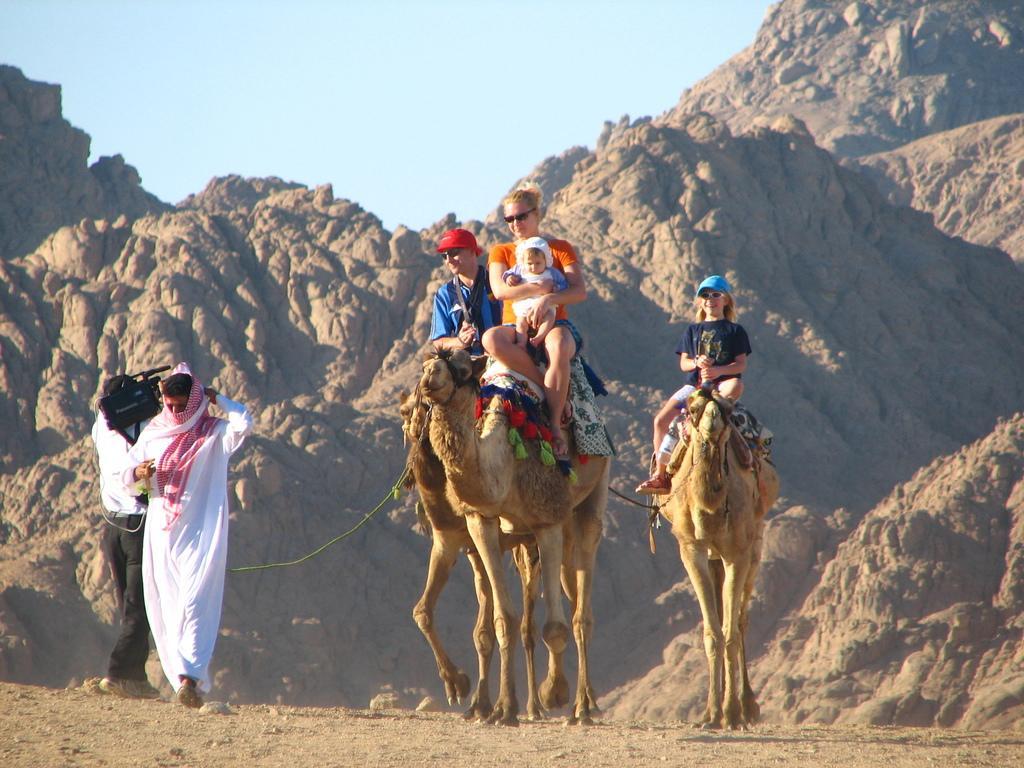In one or two sentences, can you explain what this image depicts? In this picture we can see there are some people riding the camels. A woman is holding a baby. On the left side of the camels, there is a person in the white dress is walking and another person is holding a camera. Behind the camel's there are hills and the sky. 